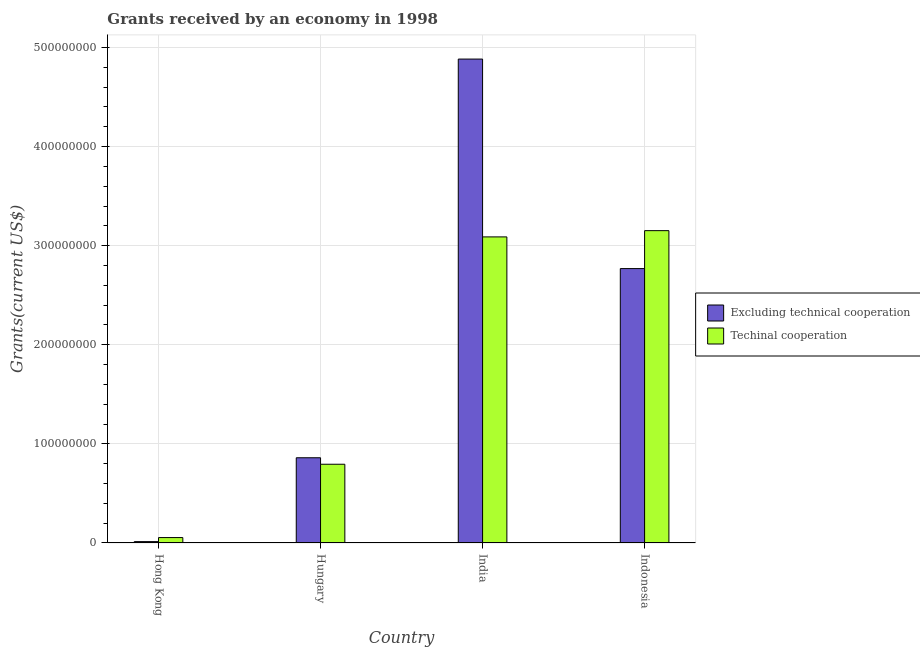How many different coloured bars are there?
Make the answer very short. 2. Are the number of bars on each tick of the X-axis equal?
Your answer should be compact. Yes. How many bars are there on the 2nd tick from the left?
Offer a very short reply. 2. How many bars are there on the 1st tick from the right?
Offer a terse response. 2. What is the label of the 1st group of bars from the left?
Your response must be concise. Hong Kong. What is the amount of grants received(excluding technical cooperation) in Indonesia?
Your answer should be compact. 2.77e+08. Across all countries, what is the maximum amount of grants received(excluding technical cooperation)?
Provide a short and direct response. 4.88e+08. Across all countries, what is the minimum amount of grants received(including technical cooperation)?
Provide a short and direct response. 5.47e+06. In which country was the amount of grants received(excluding technical cooperation) maximum?
Your answer should be compact. India. In which country was the amount of grants received(including technical cooperation) minimum?
Provide a short and direct response. Hong Kong. What is the total amount of grants received(excluding technical cooperation) in the graph?
Keep it short and to the point. 8.53e+08. What is the difference between the amount of grants received(excluding technical cooperation) in Hong Kong and that in Hungary?
Make the answer very short. -8.46e+07. What is the difference between the amount of grants received(excluding technical cooperation) in Indonesia and the amount of grants received(including technical cooperation) in Hungary?
Provide a short and direct response. 1.97e+08. What is the average amount of grants received(including technical cooperation) per country?
Your response must be concise. 1.77e+08. What is the difference between the amount of grants received(excluding technical cooperation) and amount of grants received(including technical cooperation) in India?
Provide a succinct answer. 1.79e+08. In how many countries, is the amount of grants received(including technical cooperation) greater than 80000000 US$?
Your response must be concise. 2. What is the ratio of the amount of grants received(excluding technical cooperation) in India to that in Indonesia?
Offer a terse response. 1.76. Is the difference between the amount of grants received(including technical cooperation) in Hong Kong and Indonesia greater than the difference between the amount of grants received(excluding technical cooperation) in Hong Kong and Indonesia?
Your answer should be compact. No. What is the difference between the highest and the second highest amount of grants received(excluding technical cooperation)?
Provide a succinct answer. 2.11e+08. What is the difference between the highest and the lowest amount of grants received(excluding technical cooperation)?
Your response must be concise. 4.87e+08. What does the 2nd bar from the left in Hungary represents?
Provide a succinct answer. Techinal cooperation. What does the 2nd bar from the right in India represents?
Keep it short and to the point. Excluding technical cooperation. How many bars are there?
Your answer should be very brief. 8. What is the difference between two consecutive major ticks on the Y-axis?
Offer a terse response. 1.00e+08. Are the values on the major ticks of Y-axis written in scientific E-notation?
Your response must be concise. No. Does the graph contain any zero values?
Keep it short and to the point. No. How are the legend labels stacked?
Ensure brevity in your answer.  Vertical. What is the title of the graph?
Give a very brief answer. Grants received by an economy in 1998. Does "Diesel" appear as one of the legend labels in the graph?
Ensure brevity in your answer.  No. What is the label or title of the Y-axis?
Your answer should be very brief. Grants(current US$). What is the Grants(current US$) in Excluding technical cooperation in Hong Kong?
Your response must be concise. 1.39e+06. What is the Grants(current US$) of Techinal cooperation in Hong Kong?
Provide a short and direct response. 5.47e+06. What is the Grants(current US$) of Excluding technical cooperation in Hungary?
Your answer should be very brief. 8.60e+07. What is the Grants(current US$) of Techinal cooperation in Hungary?
Give a very brief answer. 7.94e+07. What is the Grants(current US$) in Excluding technical cooperation in India?
Provide a short and direct response. 4.88e+08. What is the Grants(current US$) in Techinal cooperation in India?
Offer a very short reply. 3.09e+08. What is the Grants(current US$) in Excluding technical cooperation in Indonesia?
Keep it short and to the point. 2.77e+08. What is the Grants(current US$) in Techinal cooperation in Indonesia?
Your response must be concise. 3.15e+08. Across all countries, what is the maximum Grants(current US$) of Excluding technical cooperation?
Offer a terse response. 4.88e+08. Across all countries, what is the maximum Grants(current US$) in Techinal cooperation?
Your answer should be very brief. 3.15e+08. Across all countries, what is the minimum Grants(current US$) in Excluding technical cooperation?
Provide a succinct answer. 1.39e+06. Across all countries, what is the minimum Grants(current US$) in Techinal cooperation?
Ensure brevity in your answer.  5.47e+06. What is the total Grants(current US$) of Excluding technical cooperation in the graph?
Offer a terse response. 8.53e+08. What is the total Grants(current US$) in Techinal cooperation in the graph?
Your answer should be compact. 7.09e+08. What is the difference between the Grants(current US$) in Excluding technical cooperation in Hong Kong and that in Hungary?
Your response must be concise. -8.46e+07. What is the difference between the Grants(current US$) of Techinal cooperation in Hong Kong and that in Hungary?
Keep it short and to the point. -7.40e+07. What is the difference between the Grants(current US$) of Excluding technical cooperation in Hong Kong and that in India?
Keep it short and to the point. -4.87e+08. What is the difference between the Grants(current US$) of Techinal cooperation in Hong Kong and that in India?
Keep it short and to the point. -3.03e+08. What is the difference between the Grants(current US$) of Excluding technical cooperation in Hong Kong and that in Indonesia?
Give a very brief answer. -2.75e+08. What is the difference between the Grants(current US$) in Techinal cooperation in Hong Kong and that in Indonesia?
Provide a succinct answer. -3.10e+08. What is the difference between the Grants(current US$) of Excluding technical cooperation in Hungary and that in India?
Keep it short and to the point. -4.02e+08. What is the difference between the Grants(current US$) of Techinal cooperation in Hungary and that in India?
Offer a terse response. -2.29e+08. What is the difference between the Grants(current US$) of Excluding technical cooperation in Hungary and that in Indonesia?
Your answer should be very brief. -1.91e+08. What is the difference between the Grants(current US$) in Techinal cooperation in Hungary and that in Indonesia?
Your response must be concise. -2.36e+08. What is the difference between the Grants(current US$) in Excluding technical cooperation in India and that in Indonesia?
Give a very brief answer. 2.11e+08. What is the difference between the Grants(current US$) in Techinal cooperation in India and that in Indonesia?
Your answer should be compact. -6.32e+06. What is the difference between the Grants(current US$) in Excluding technical cooperation in Hong Kong and the Grants(current US$) in Techinal cooperation in Hungary?
Provide a succinct answer. -7.81e+07. What is the difference between the Grants(current US$) in Excluding technical cooperation in Hong Kong and the Grants(current US$) in Techinal cooperation in India?
Offer a terse response. -3.07e+08. What is the difference between the Grants(current US$) of Excluding technical cooperation in Hong Kong and the Grants(current US$) of Techinal cooperation in Indonesia?
Ensure brevity in your answer.  -3.14e+08. What is the difference between the Grants(current US$) in Excluding technical cooperation in Hungary and the Grants(current US$) in Techinal cooperation in India?
Provide a succinct answer. -2.23e+08. What is the difference between the Grants(current US$) of Excluding technical cooperation in Hungary and the Grants(current US$) of Techinal cooperation in Indonesia?
Offer a terse response. -2.29e+08. What is the difference between the Grants(current US$) of Excluding technical cooperation in India and the Grants(current US$) of Techinal cooperation in Indonesia?
Your response must be concise. 1.73e+08. What is the average Grants(current US$) of Excluding technical cooperation per country?
Make the answer very short. 2.13e+08. What is the average Grants(current US$) of Techinal cooperation per country?
Your answer should be compact. 1.77e+08. What is the difference between the Grants(current US$) of Excluding technical cooperation and Grants(current US$) of Techinal cooperation in Hong Kong?
Your answer should be very brief. -4.08e+06. What is the difference between the Grants(current US$) of Excluding technical cooperation and Grants(current US$) of Techinal cooperation in Hungary?
Give a very brief answer. 6.54e+06. What is the difference between the Grants(current US$) of Excluding technical cooperation and Grants(current US$) of Techinal cooperation in India?
Your response must be concise. 1.79e+08. What is the difference between the Grants(current US$) in Excluding technical cooperation and Grants(current US$) in Techinal cooperation in Indonesia?
Give a very brief answer. -3.83e+07. What is the ratio of the Grants(current US$) in Excluding technical cooperation in Hong Kong to that in Hungary?
Ensure brevity in your answer.  0.02. What is the ratio of the Grants(current US$) of Techinal cooperation in Hong Kong to that in Hungary?
Make the answer very short. 0.07. What is the ratio of the Grants(current US$) in Excluding technical cooperation in Hong Kong to that in India?
Provide a short and direct response. 0. What is the ratio of the Grants(current US$) in Techinal cooperation in Hong Kong to that in India?
Make the answer very short. 0.02. What is the ratio of the Grants(current US$) in Excluding technical cooperation in Hong Kong to that in Indonesia?
Give a very brief answer. 0.01. What is the ratio of the Grants(current US$) of Techinal cooperation in Hong Kong to that in Indonesia?
Keep it short and to the point. 0.02. What is the ratio of the Grants(current US$) in Excluding technical cooperation in Hungary to that in India?
Ensure brevity in your answer.  0.18. What is the ratio of the Grants(current US$) of Techinal cooperation in Hungary to that in India?
Ensure brevity in your answer.  0.26. What is the ratio of the Grants(current US$) of Excluding technical cooperation in Hungary to that in Indonesia?
Give a very brief answer. 0.31. What is the ratio of the Grants(current US$) of Techinal cooperation in Hungary to that in Indonesia?
Give a very brief answer. 0.25. What is the ratio of the Grants(current US$) in Excluding technical cooperation in India to that in Indonesia?
Your answer should be compact. 1.76. What is the ratio of the Grants(current US$) of Techinal cooperation in India to that in Indonesia?
Give a very brief answer. 0.98. What is the difference between the highest and the second highest Grants(current US$) of Excluding technical cooperation?
Provide a short and direct response. 2.11e+08. What is the difference between the highest and the second highest Grants(current US$) in Techinal cooperation?
Give a very brief answer. 6.32e+06. What is the difference between the highest and the lowest Grants(current US$) in Excluding technical cooperation?
Offer a terse response. 4.87e+08. What is the difference between the highest and the lowest Grants(current US$) in Techinal cooperation?
Make the answer very short. 3.10e+08. 